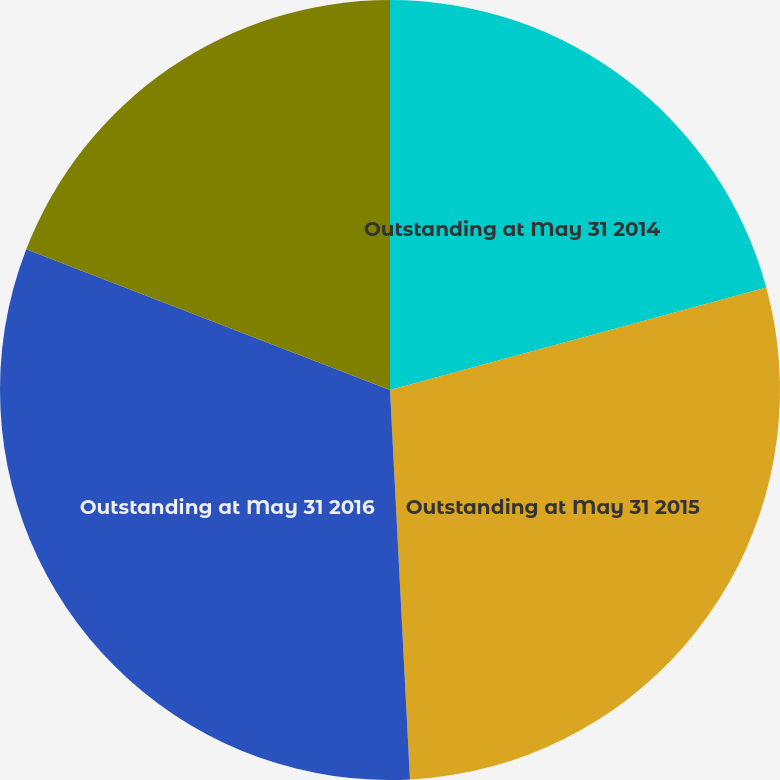Convert chart to OTSL. <chart><loc_0><loc_0><loc_500><loc_500><pie_chart><fcel>Outstanding at May 31 2014<fcel>Outstanding at May 31 2015<fcel>Outstanding at May 31 2016<fcel>Options vested and exercisable<nl><fcel>20.77%<fcel>28.42%<fcel>31.69%<fcel>19.13%<nl></chart> 